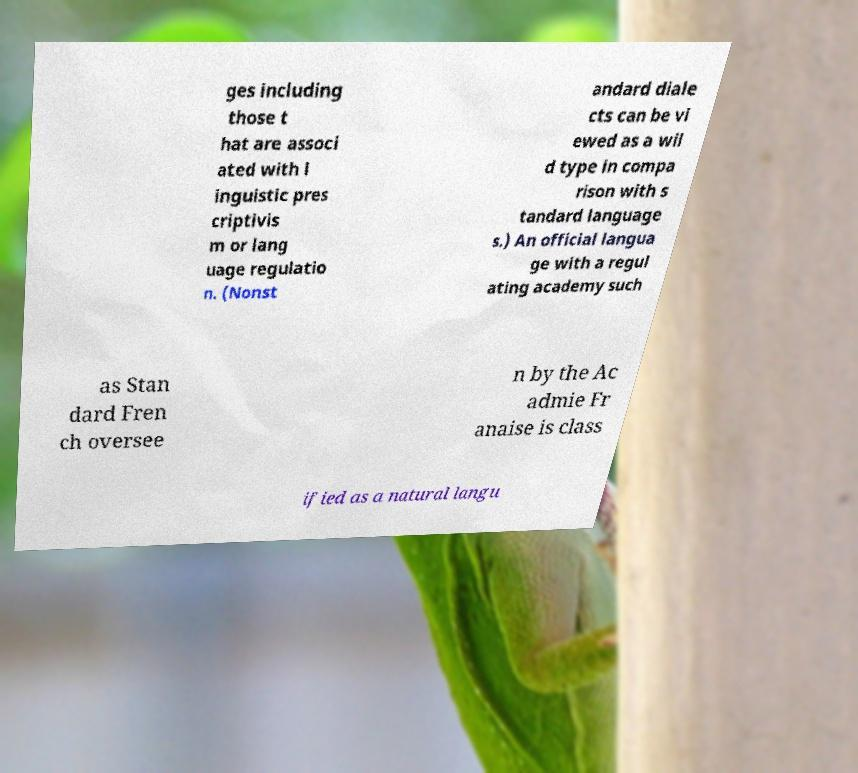Can you read and provide the text displayed in the image?This photo seems to have some interesting text. Can you extract and type it out for me? ges including those t hat are associ ated with l inguistic pres criptivis m or lang uage regulatio n. (Nonst andard diale cts can be vi ewed as a wil d type in compa rison with s tandard language s.) An official langua ge with a regul ating academy such as Stan dard Fren ch oversee n by the Ac admie Fr anaise is class ified as a natural langu 